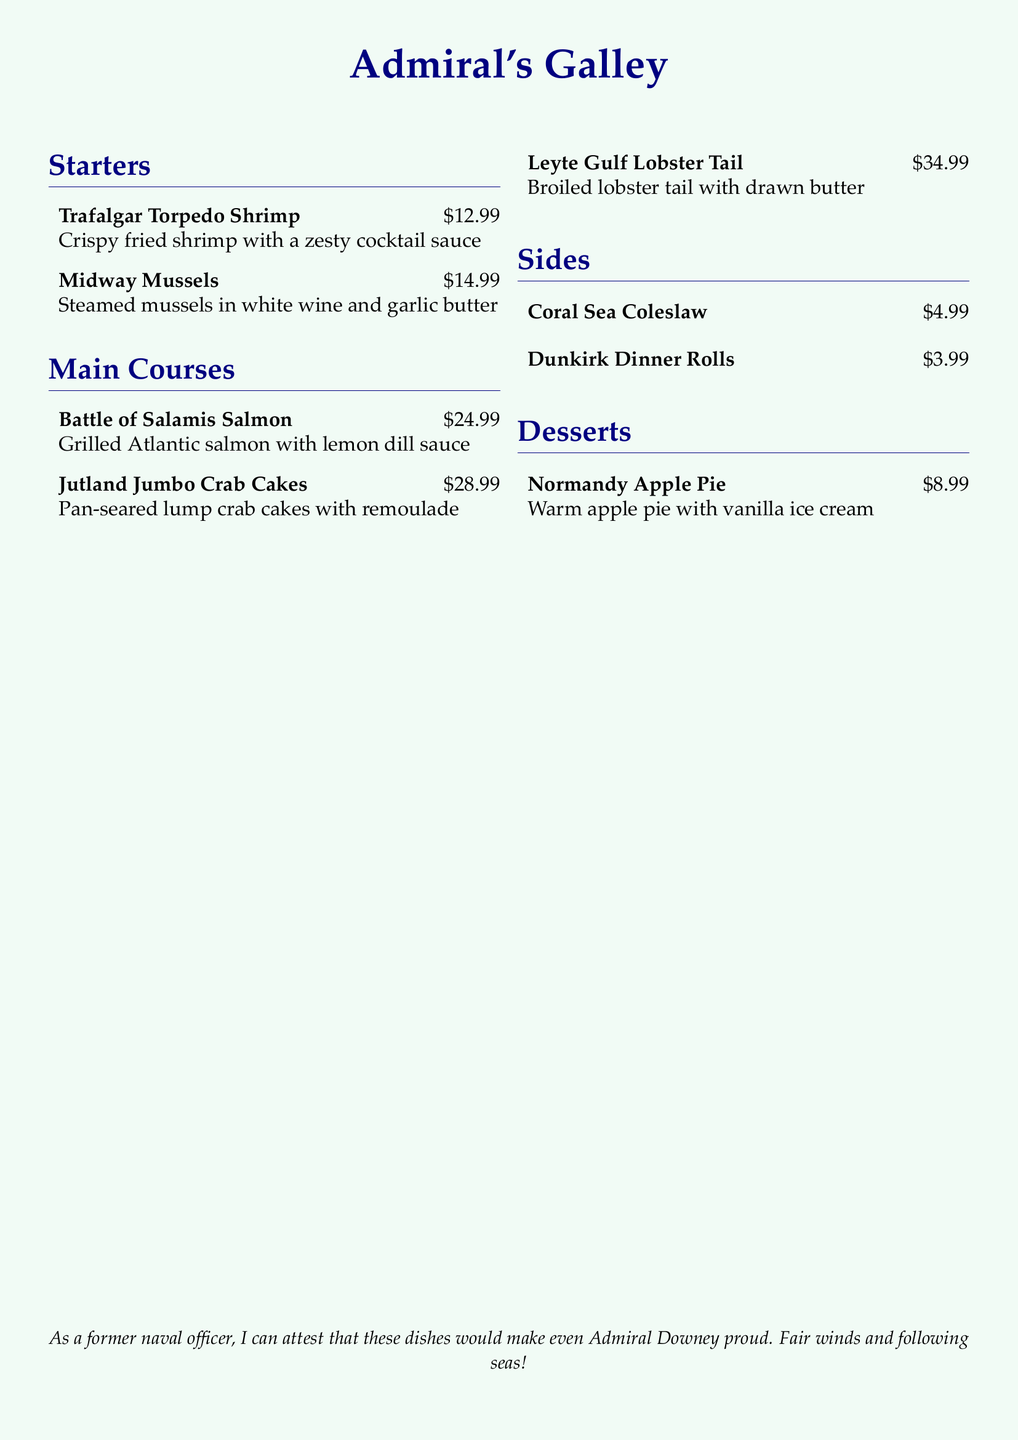What is the name of the dessert? The dessert section lists one item, "Normandy Apple Pie."
Answer: Normandy Apple Pie How much does the Jutland Jumbo Crab Cakes cost? The price for the Jutland Jumbo Crab Cakes is listed next to its name, which is $28.99.
Answer: $28.99 What is one starter on the menu? The starters section includes "Trafalgar Torpedo Shrimp" as one of the listed items.
Answer: Trafalgar Torpedo Shrimp Which dish features lobster? The main courses section includes "Leyte Gulf Lobster Tail," which specifically features lobster.
Answer: Leyte Gulf Lobster Tail What color is the background of the menu? The menu indicates that the background color is "seafoam" with a specific RGB value.
Answer: Seafoam How much do the Dunkirk Dinner Rolls cost? The cost for the Dunkirk Dinner Rolls is stated as $3.99.
Answer: $3.99 Which sauce is mentioned with the Battle of Salamis Salmon? The dish description specifies that it is served with "lemon dill sauce."
Answer: Lemon dill sauce What is the total price of all sides listed? The total is calculated by adding the individual prices, which are $4.99 and $3.99, giving a final amount of $8.98.
Answer: $8.98 How many main course items are listed on the menu? The menu specifies three main course items, including the Battle of Salamis Salmon, Jutland Jumbo Crab Cakes, and Leyte Gulf Lobster Tail.
Answer: Three 